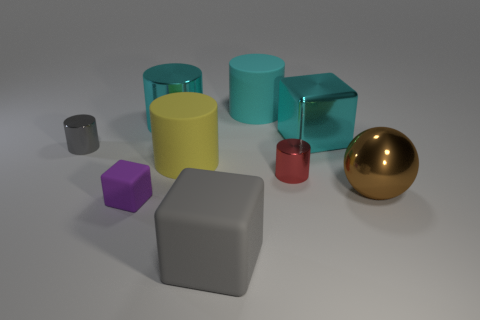Subtract all yellow matte cylinders. How many cylinders are left? 4 Subtract all blue blocks. How many cyan cylinders are left? 2 Subtract all cyan blocks. How many blocks are left? 2 Subtract 1 blocks. How many blocks are left? 2 Subtract all cylinders. How many objects are left? 4 Subtract all purple cylinders. Subtract all brown spheres. How many cylinders are left? 5 Subtract 1 yellow cylinders. How many objects are left? 8 Subtract all yellow cylinders. Subtract all yellow rubber things. How many objects are left? 7 Add 3 tiny gray metal cylinders. How many tiny gray metal cylinders are left? 4 Add 5 big red balls. How many big red balls exist? 5 